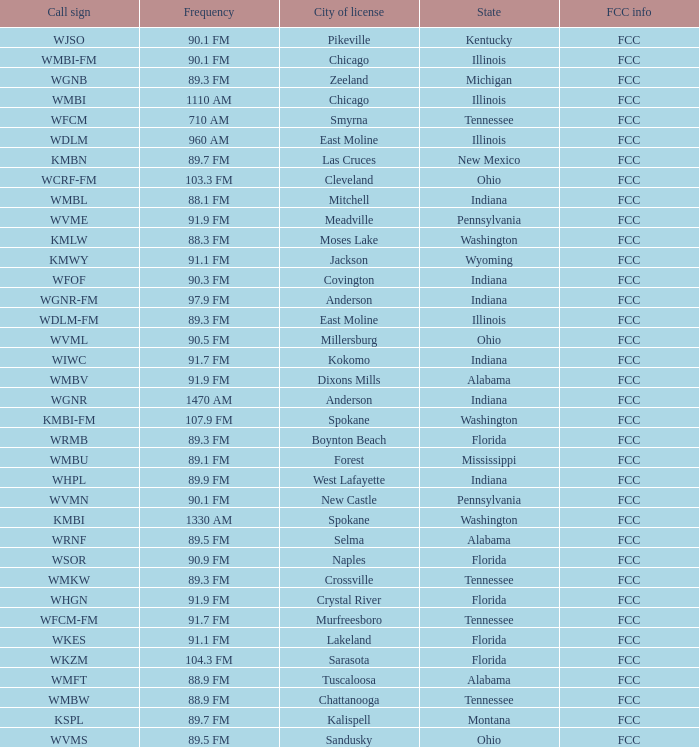What city is 103.3 FM licensed in? Cleveland. 